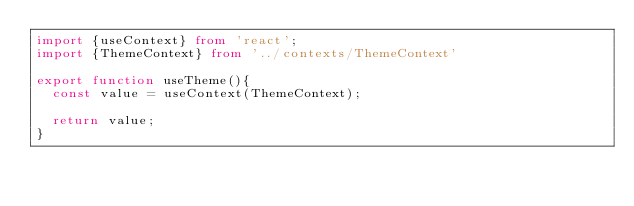Convert code to text. <code><loc_0><loc_0><loc_500><loc_500><_TypeScript_>import {useContext} from 'react';
import {ThemeContext} from '../contexts/ThemeContext'

export function useTheme(){
  const value = useContext(ThemeContext);

  return value;
}</code> 